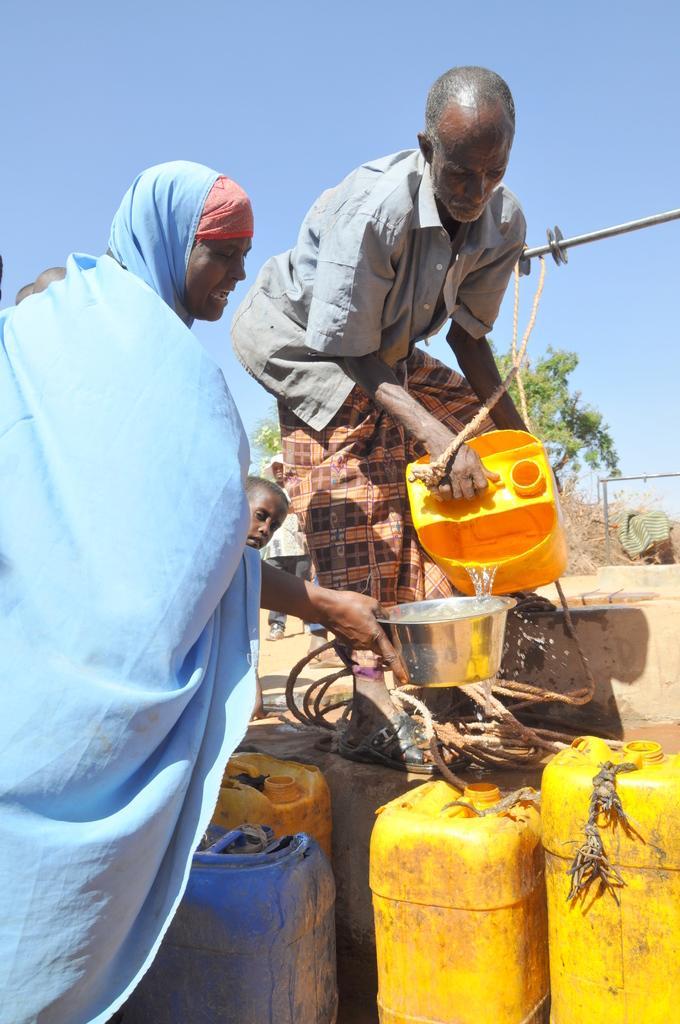Describe this image in one or two sentences. On the right there is a man who is wearing shirt and trouser. He is holding a bucket. He is standing near to the well. On the left there is a woman who is wearing a blue dress. She is holding a bowl. At the bottom we can see plastic water bottles. In the background we can see trees. At the top there is a sky. 